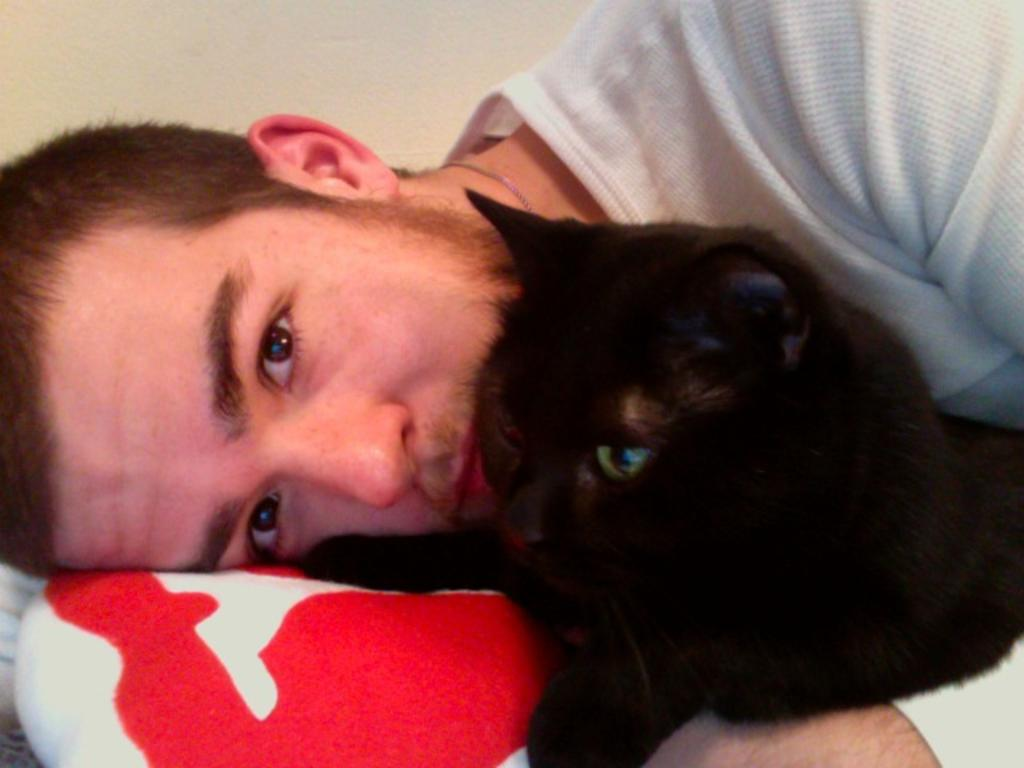What is the main subject of the image? The main subject of the image is a man. What is the man doing in the image? The man is sleeping in the image. What other living creature is present in the image? There is a black cat in the image. How is the cat positioned in relation to the man? The cat is cuddled in the man's hand. What type of chess piece is the man holding in the image? There is no chess piece present in the image. How does the team of animals help the man in the image? There is no team of animals present in the image. 